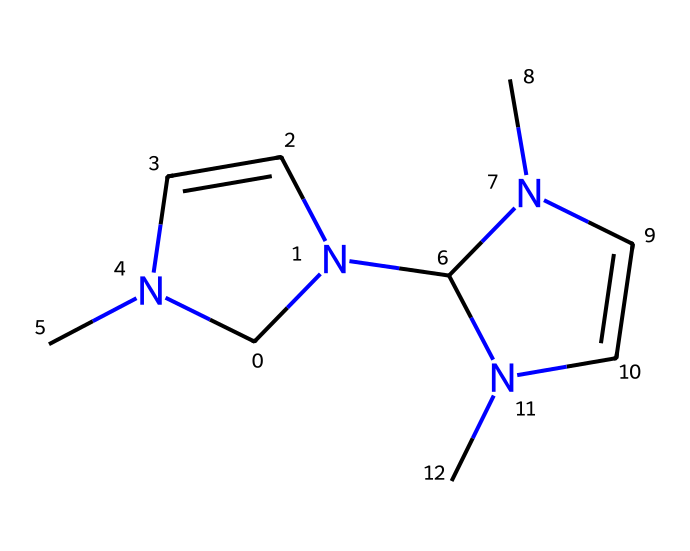what is the molecular formula of this compound? To determine the molecular formula, we need to count the number of each type of atom present in the structure. From the SMILES representation, we identify 9 carbon (C) atoms, 12 hydrogen (H) atoms, and 4 nitrogen (N) atoms. This gives us the formula C9H12N4.
Answer: C9H12N4 how many rings are there in this structure? By examining the SMILES, we can see that there are two occurrences of the number "1" indicating the start and end of a cycle in the structure. This denotes that there are two rings present in the compound.
Answer: 2 what type of carbene is represented by this structure? The structure includes nitrogen atoms in a heterocyclic arrangement with carbene functionality. Given the presence of nitrogen atoms in the ring, it indicates that this compound is classified as an N-heterocyclic carbene.
Answer: N-heterocyclic carbene why are N-heterocyclic carbenes important in catalysis? N-heterocyclic carbenes are known for their strong nucleophilic nature and ability to stabilize positive charges, making them excellent catalysts in various chemical reactions, particularly in pharmaceuticals. This stability and reactivity are crucial for facilitating reactions in pharmaceutical manufacturing.
Answer: catalysis how many nitrogen atoms are in this molecule? To find the number of nitrogen atoms, we look at the SMILES representation and count the occurrences of the letter “N.” Here, we see 4 nitrogen atoms present in the structure.
Answer: 4 what type of reactions can N-heterocyclic carbenes facilitate in pharmaceutical manufacturing? N-heterocyclic carbenes can facilitate a range of reactions, including cross-coupling reactions, catalytic hydrogenation, and various C–C bond forming reactions, making them versatile catalysts in drug synthesis.
Answer: various reactions 